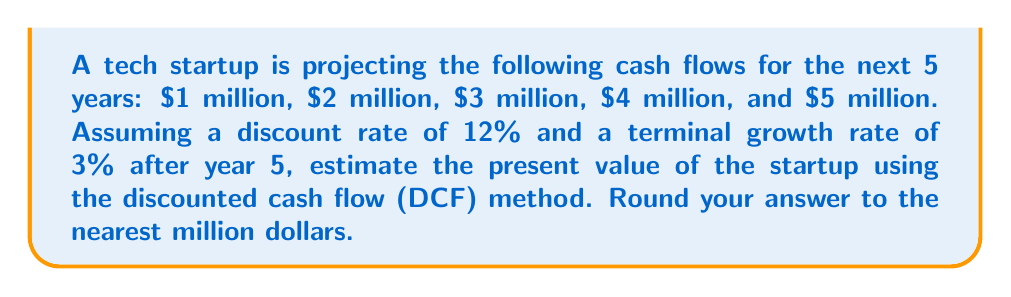Could you help me with this problem? To estimate the present value of the startup using the DCF method, we need to:

1. Calculate the present value of the projected cash flows
2. Calculate the terminal value
3. Discount the terminal value to present value
4. Sum up all the present values

Step 1: Present value of projected cash flows

Using the formula: $PV = \frac{CF_t}{(1+r)^t}$, where $CF_t$ is the cash flow at time $t$, and $r$ is the discount rate.

Year 1: $PV_1 = \frac{1,000,000}{(1+0.12)^1} = 892,857$
Year 2: $PV_2 = \frac{2,000,000}{(1+0.12)^2} = 1,592,945$
Year 3: $PV_3 = \frac{3,000,000}{(1+0.12)^3} = 2,134,007$
Year 4: $PV_4 = \frac{4,000,000}{(1+0.12)^4} = 2,541,465$
Year 5: $PV_5 = \frac{5,000,000}{(1+0.12)^5} = 2,832,777$

Sum of PV of cash flows: $9,994,051$

Step 2: Terminal value

Using the Gordon Growth Model: $TV = \frac{CF_5 \times (1+g)}{(r-g)}$

Where $CF_5$ is the cash flow in year 5, $g$ is the terminal growth rate, and $r$ is the discount rate.

$TV = \frac{5,000,000 \times (1+0.03)}{(0.12-0.03)} = 57,222,222$

Step 3: Present value of terminal value

$PV_{TV} = \frac{57,222,222}{(1+0.12)^5} = 32,455,344$

Step 4: Sum up all present values

Total PV = PV of cash flows + PV of terminal value
$= 9,994,051 + 32,455,344 = 42,449,395$
Answer: $42 million 